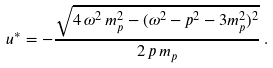Convert formula to latex. <formula><loc_0><loc_0><loc_500><loc_500>u ^ { * } = - { \frac { \sqrt { 4 \, \omega ^ { 2 } \, m _ { p } ^ { 2 } - ( \omega ^ { 2 } - p ^ { 2 } - 3 m _ { p } ^ { 2 } ) ^ { 2 } } } { 2 \, p \, m _ { p } } } \, .</formula> 